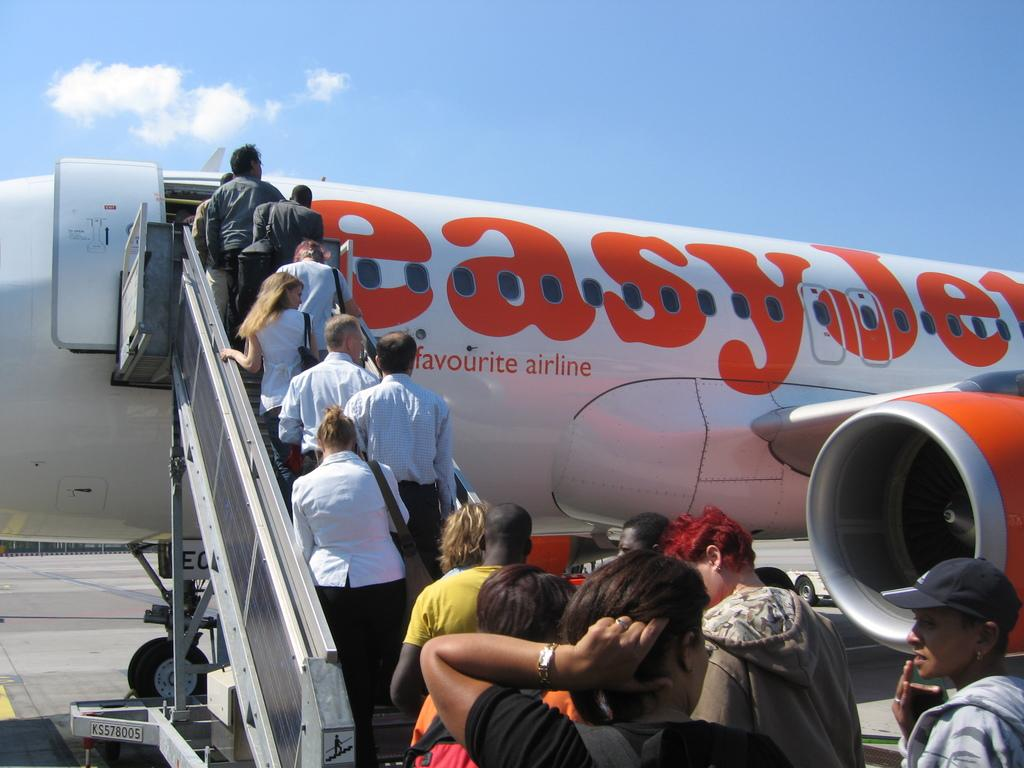<image>
Present a compact description of the photo's key features. an easyjey plant is being boarded by many people 